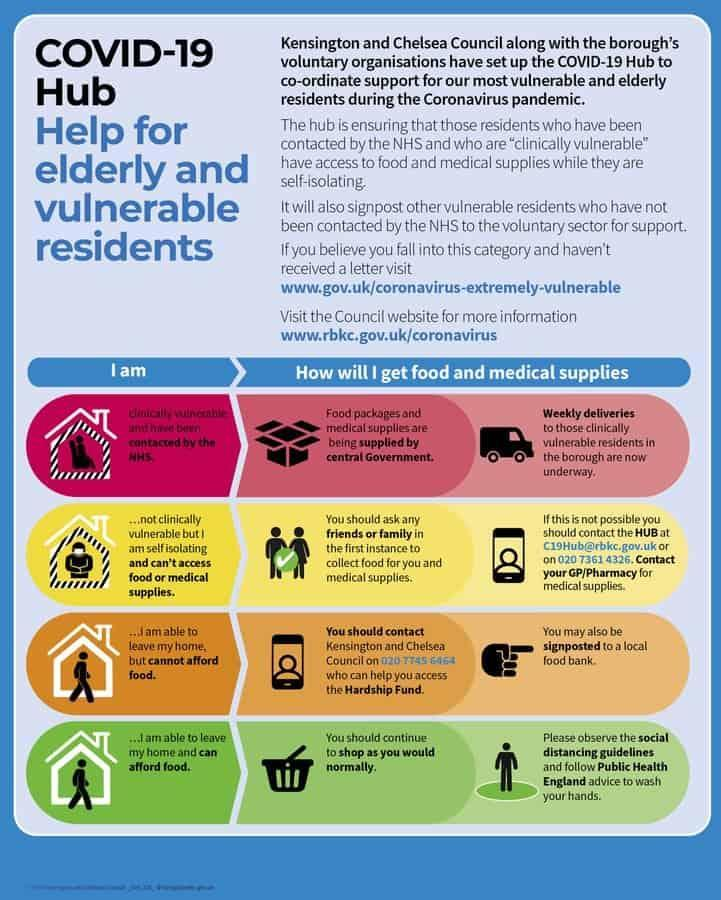How many people can leave their own homes?
Answer the question with a short phrase. 2 